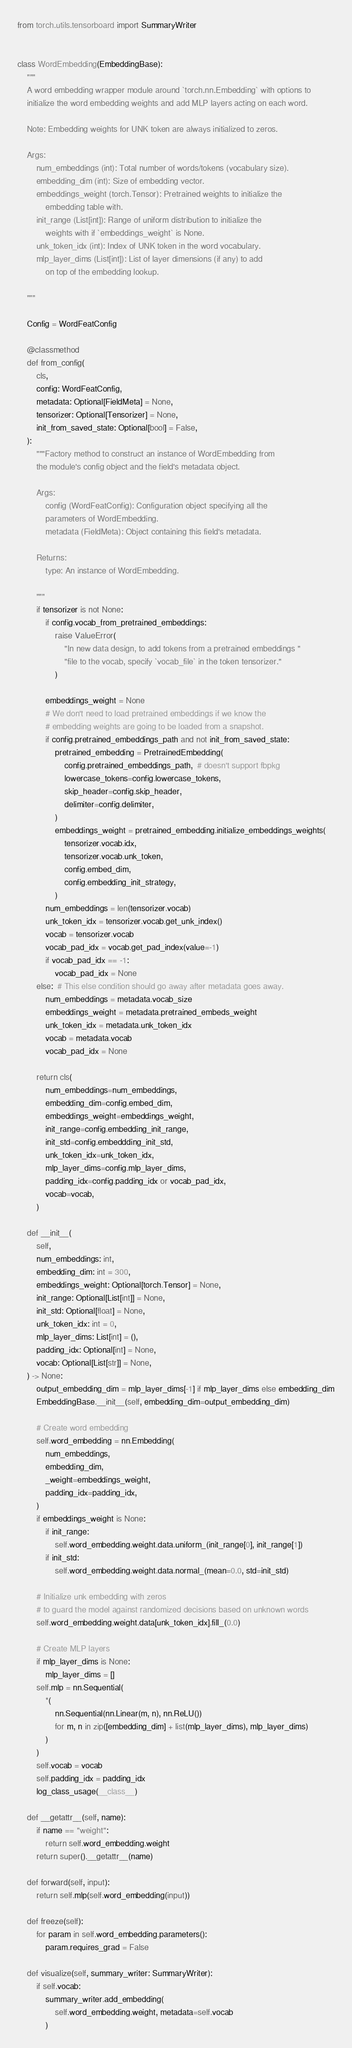<code> <loc_0><loc_0><loc_500><loc_500><_Python_>from torch.utils.tensorboard import SummaryWriter


class WordEmbedding(EmbeddingBase):
    """
    A word embedding wrapper module around `torch.nn.Embedding` with options to
    initialize the word embedding weights and add MLP layers acting on each word.

    Note: Embedding weights for UNK token are always initialized to zeros.

    Args:
        num_embeddings (int): Total number of words/tokens (vocabulary size).
        embedding_dim (int): Size of embedding vector.
        embeddings_weight (torch.Tensor): Pretrained weights to initialize the
            embedding table with.
        init_range (List[int]): Range of uniform distribution to initialize the
            weights with if `embeddings_weight` is None.
        unk_token_idx (int): Index of UNK token in the word vocabulary.
        mlp_layer_dims (List[int]): List of layer dimensions (if any) to add
            on top of the embedding lookup.

    """

    Config = WordFeatConfig

    @classmethod
    def from_config(
        cls,
        config: WordFeatConfig,
        metadata: Optional[FieldMeta] = None,
        tensorizer: Optional[Tensorizer] = None,
        init_from_saved_state: Optional[bool] = False,
    ):
        """Factory method to construct an instance of WordEmbedding from
        the module's config object and the field's metadata object.

        Args:
            config (WordFeatConfig): Configuration object specifying all the
            parameters of WordEmbedding.
            metadata (FieldMeta): Object containing this field's metadata.

        Returns:
            type: An instance of WordEmbedding.

        """
        if tensorizer is not None:
            if config.vocab_from_pretrained_embeddings:
                raise ValueError(
                    "In new data design, to add tokens from a pretrained embeddings "
                    "file to the vocab, specify `vocab_file` in the token tensorizer."
                )

            embeddings_weight = None
            # We don't need to load pretrained embeddings if we know the
            # embedding weights are going to be loaded from a snapshot.
            if config.pretrained_embeddings_path and not init_from_saved_state:
                pretrained_embedding = PretrainedEmbedding(
                    config.pretrained_embeddings_path,  # doesn't support fbpkg
                    lowercase_tokens=config.lowercase_tokens,
                    skip_header=config.skip_header,
                    delimiter=config.delimiter,
                )
                embeddings_weight = pretrained_embedding.initialize_embeddings_weights(
                    tensorizer.vocab.idx,
                    tensorizer.vocab.unk_token,
                    config.embed_dim,
                    config.embedding_init_strategy,
                )
            num_embeddings = len(tensorizer.vocab)
            unk_token_idx = tensorizer.vocab.get_unk_index()
            vocab = tensorizer.vocab
            vocab_pad_idx = vocab.get_pad_index(value=-1)
            if vocab_pad_idx == -1:
                vocab_pad_idx = None
        else:  # This else condition should go away after metadata goes away.
            num_embeddings = metadata.vocab_size
            embeddings_weight = metadata.pretrained_embeds_weight
            unk_token_idx = metadata.unk_token_idx
            vocab = metadata.vocab
            vocab_pad_idx = None

        return cls(
            num_embeddings=num_embeddings,
            embedding_dim=config.embed_dim,
            embeddings_weight=embeddings_weight,
            init_range=config.embedding_init_range,
            init_std=config.embeddding_init_std,
            unk_token_idx=unk_token_idx,
            mlp_layer_dims=config.mlp_layer_dims,
            padding_idx=config.padding_idx or vocab_pad_idx,
            vocab=vocab,
        )

    def __init__(
        self,
        num_embeddings: int,
        embedding_dim: int = 300,
        embeddings_weight: Optional[torch.Tensor] = None,
        init_range: Optional[List[int]] = None,
        init_std: Optional[float] = None,
        unk_token_idx: int = 0,
        mlp_layer_dims: List[int] = (),
        padding_idx: Optional[int] = None,
        vocab: Optional[List[str]] = None,
    ) -> None:
        output_embedding_dim = mlp_layer_dims[-1] if mlp_layer_dims else embedding_dim
        EmbeddingBase.__init__(self, embedding_dim=output_embedding_dim)

        # Create word embedding
        self.word_embedding = nn.Embedding(
            num_embeddings,
            embedding_dim,
            _weight=embeddings_weight,
            padding_idx=padding_idx,
        )
        if embeddings_weight is None:
            if init_range:
                self.word_embedding.weight.data.uniform_(init_range[0], init_range[1])
            if init_std:
                self.word_embedding.weight.data.normal_(mean=0.0, std=init_std)

        # Initialize unk embedding with zeros
        # to guard the model against randomized decisions based on unknown words
        self.word_embedding.weight.data[unk_token_idx].fill_(0.0)

        # Create MLP layers
        if mlp_layer_dims is None:
            mlp_layer_dims = []
        self.mlp = nn.Sequential(
            *(
                nn.Sequential(nn.Linear(m, n), nn.ReLU())
                for m, n in zip([embedding_dim] + list(mlp_layer_dims), mlp_layer_dims)
            )
        )
        self.vocab = vocab
        self.padding_idx = padding_idx
        log_class_usage(__class__)

    def __getattr__(self, name):
        if name == "weight":
            return self.word_embedding.weight
        return super().__getattr__(name)

    def forward(self, input):
        return self.mlp(self.word_embedding(input))

    def freeze(self):
        for param in self.word_embedding.parameters():
            param.requires_grad = False

    def visualize(self, summary_writer: SummaryWriter):
        if self.vocab:
            summary_writer.add_embedding(
                self.word_embedding.weight, metadata=self.vocab
            )
</code> 